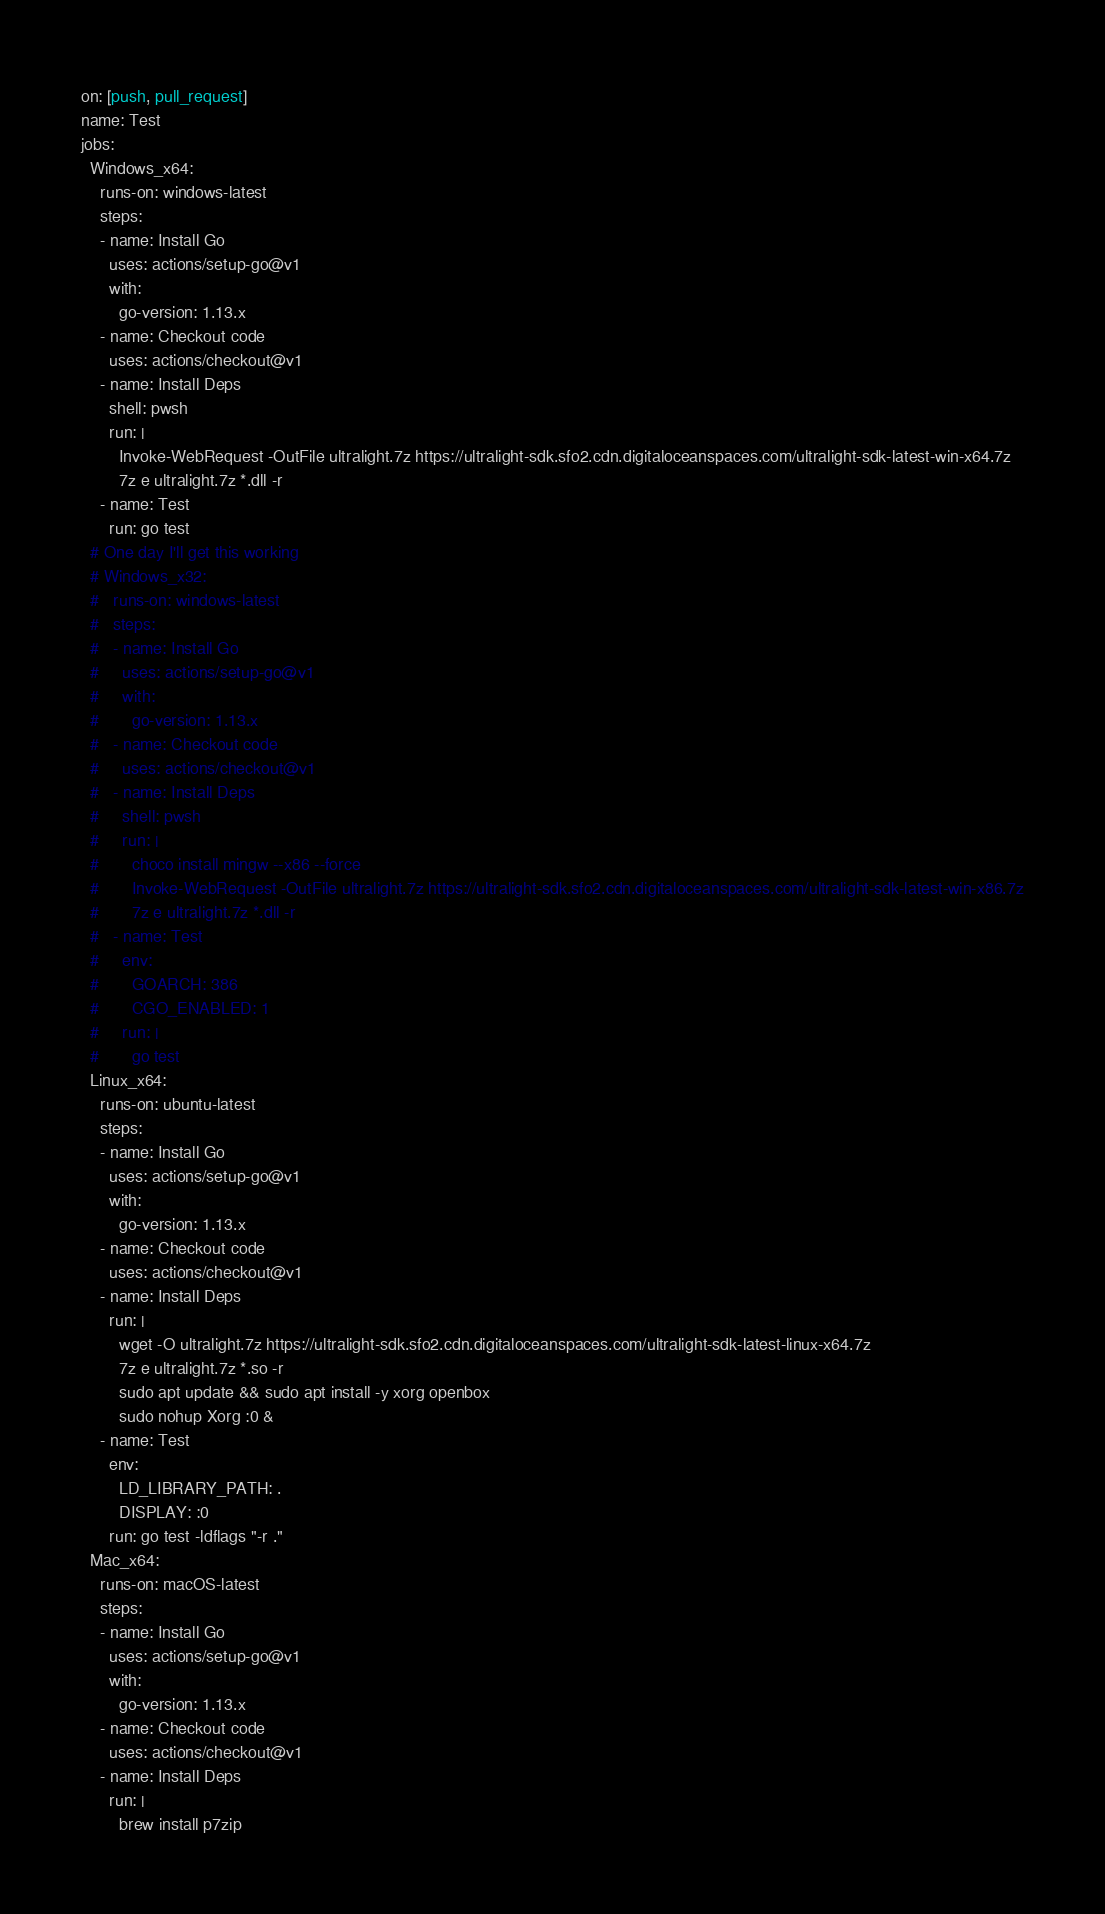<code> <loc_0><loc_0><loc_500><loc_500><_YAML_>on: [push, pull_request]
name: Test
jobs:
  Windows_x64:
    runs-on: windows-latest
    steps:
    - name: Install Go
      uses: actions/setup-go@v1
      with:
        go-version: 1.13.x
    - name: Checkout code
      uses: actions/checkout@v1
    - name: Install Deps
      shell: pwsh
      run: |
        Invoke-WebRequest -OutFile ultralight.7z https://ultralight-sdk.sfo2.cdn.digitaloceanspaces.com/ultralight-sdk-latest-win-x64.7z
        7z e ultralight.7z *.dll -r
    - name: Test
      run: go test
  # One day I'll get this working
  # Windows_x32:
  #   runs-on: windows-latest
  #   steps:
  #   - name: Install Go
  #     uses: actions/setup-go@v1
  #     with:
  #       go-version: 1.13.x
  #   - name: Checkout code
  #     uses: actions/checkout@v1
  #   - name: Install Deps
  #     shell: pwsh
  #     run: |
  #       choco install mingw --x86 --force
  #       Invoke-WebRequest -OutFile ultralight.7z https://ultralight-sdk.sfo2.cdn.digitaloceanspaces.com/ultralight-sdk-latest-win-x86.7z
  #       7z e ultralight.7z *.dll -r
  #   - name: Test
  #     env:
  #       GOARCH: 386
  #       CGO_ENABLED: 1
  #     run: |
  #       go test
  Linux_x64:
    runs-on: ubuntu-latest
    steps:
    - name: Install Go
      uses: actions/setup-go@v1
      with:
        go-version: 1.13.x
    - name: Checkout code
      uses: actions/checkout@v1
    - name: Install Deps
      run: |
        wget -O ultralight.7z https://ultralight-sdk.sfo2.cdn.digitaloceanspaces.com/ultralight-sdk-latest-linux-x64.7z
        7z e ultralight.7z *.so -r
        sudo apt update && sudo apt install -y xorg openbox
        sudo nohup Xorg :0 &
    - name: Test
      env:
        LD_LIBRARY_PATH: .
        DISPLAY: :0
      run: go test -ldflags "-r ."
  Mac_x64:
    runs-on: macOS-latest
    steps:
    - name: Install Go
      uses: actions/setup-go@v1
      with:
        go-version: 1.13.x
    - name: Checkout code
      uses: actions/checkout@v1
    - name: Install Deps
      run: |
        brew install p7zip</code> 